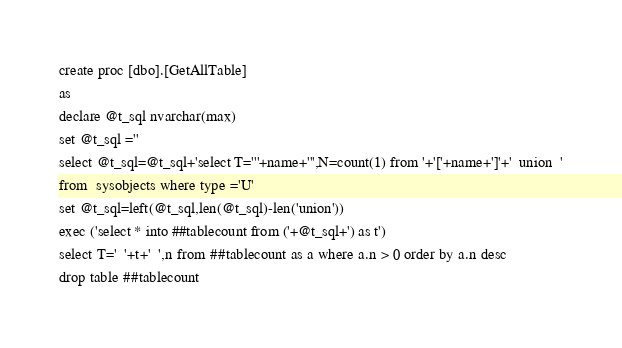Convert code to text. <code><loc_0><loc_0><loc_500><loc_500><_SQL_>create proc [dbo].[GetAllTable]
as
declare @t_sql nvarchar(max)
set @t_sql =''
select @t_sql=@t_sql+'select T='''+name+''',N=count(1) from '+'['+name+']'+'  union  '
from  sysobjects where type ='U'
set @t_sql=left(@t_sql,len(@t_sql)-len('union'))
exec ('select * into ##tablecount from ('+@t_sql+') as t')
select T='  '+t+'  ',n from ##tablecount as a where a.n > 0 order by a.n desc
drop table ##tablecount</code> 